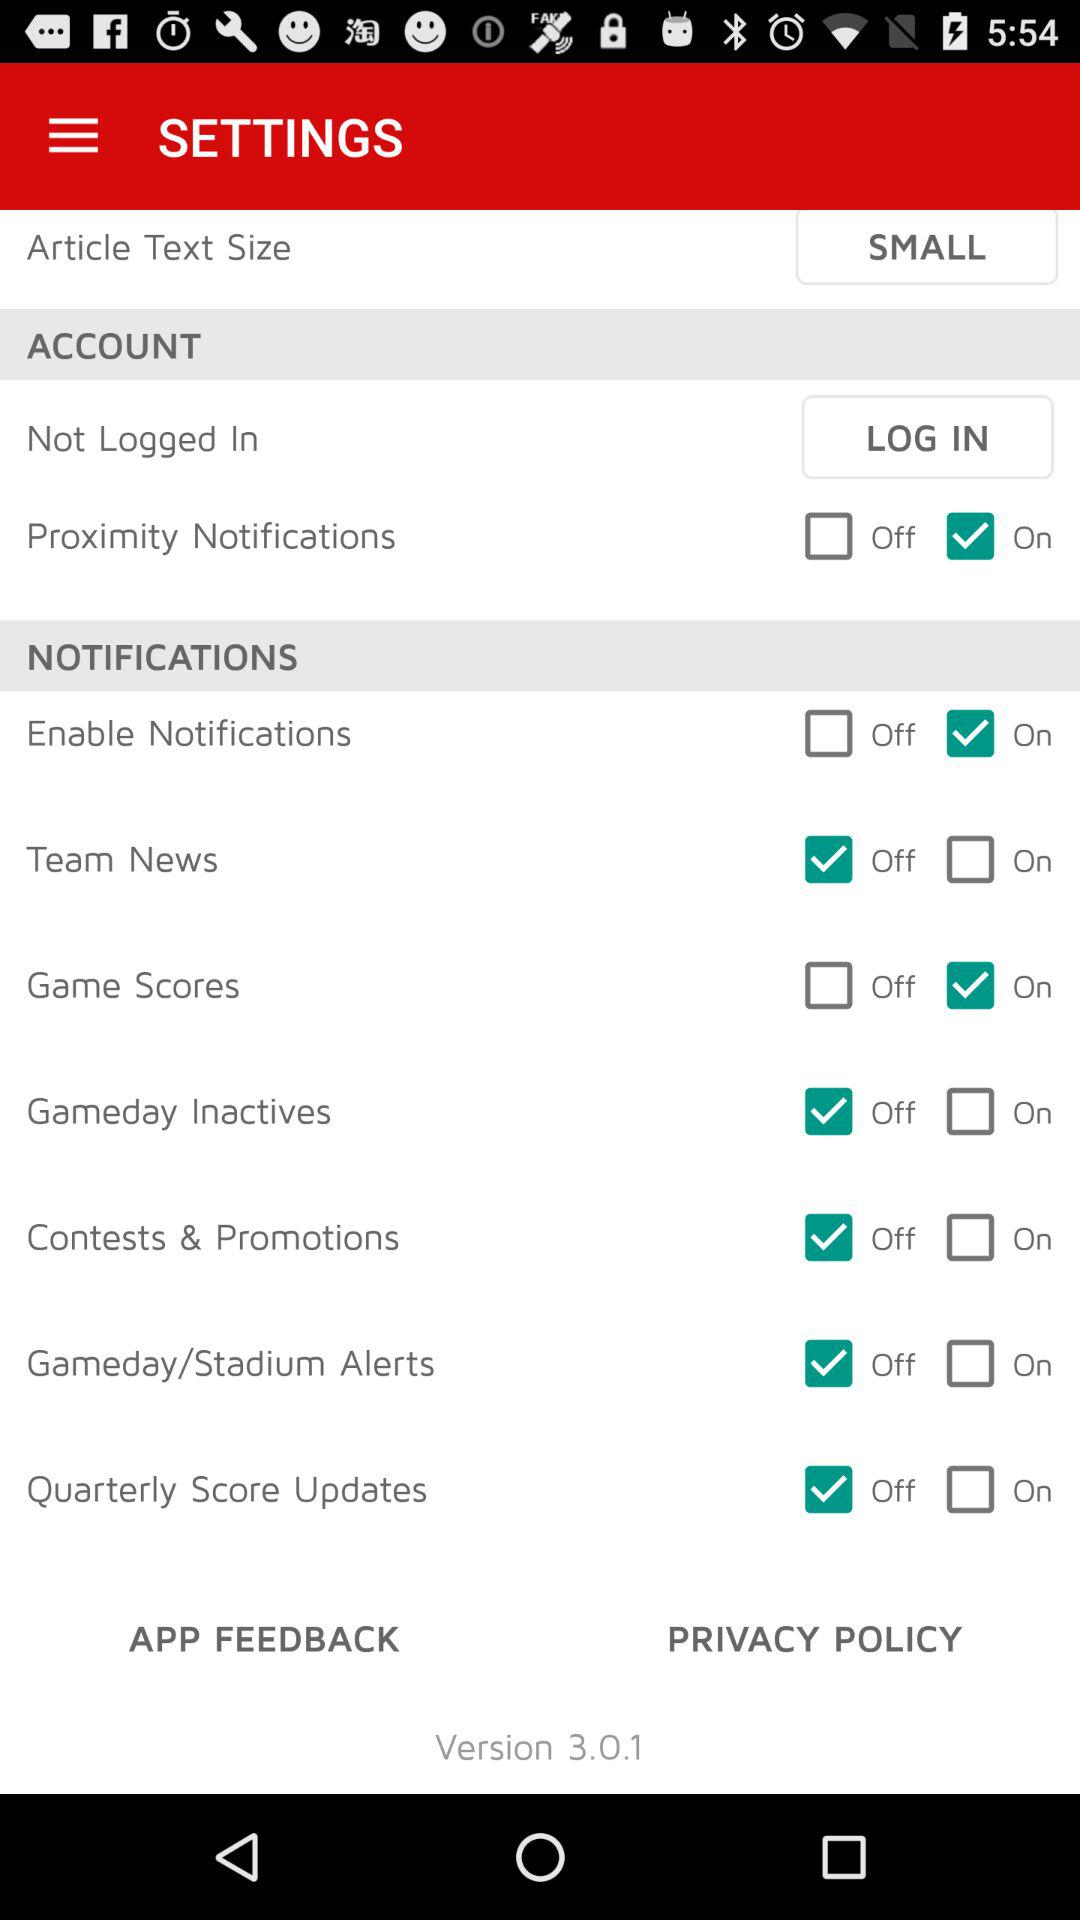What is the article text size? The article text size is "SMALL". 